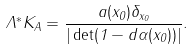<formula> <loc_0><loc_0><loc_500><loc_500>\Lambda ^ { \ast } K _ { A } = \frac { a ( x _ { 0 } ) \delta _ { x _ { 0 } } } { | \det ( 1 - d \alpha ( x _ { 0 } ) ) | } .</formula> 